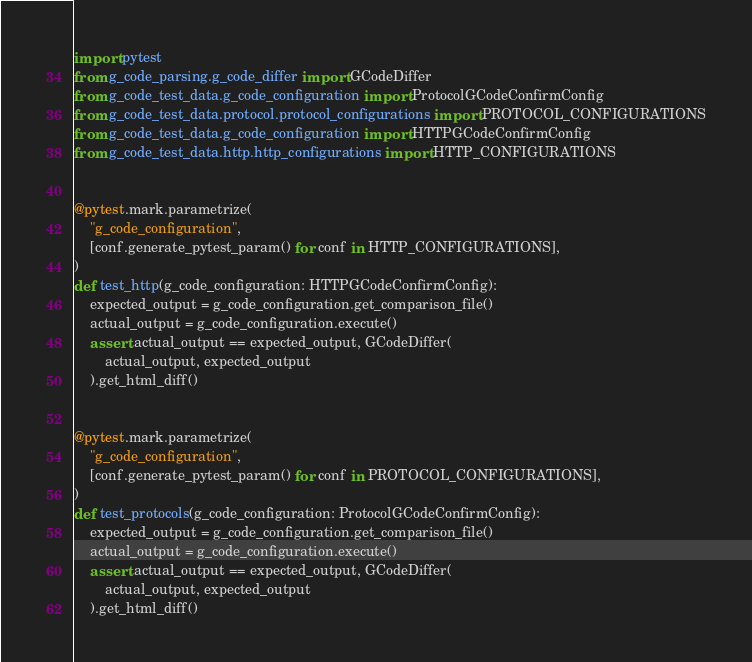Convert code to text. <code><loc_0><loc_0><loc_500><loc_500><_Python_>import pytest
from g_code_parsing.g_code_differ import GCodeDiffer
from g_code_test_data.g_code_configuration import ProtocolGCodeConfirmConfig
from g_code_test_data.protocol.protocol_configurations import PROTOCOL_CONFIGURATIONS
from g_code_test_data.g_code_configuration import HTTPGCodeConfirmConfig
from g_code_test_data.http.http_configurations import HTTP_CONFIGURATIONS


@pytest.mark.parametrize(
    "g_code_configuration",
    [conf.generate_pytest_param() for conf in HTTP_CONFIGURATIONS],
)
def test_http(g_code_configuration: HTTPGCodeConfirmConfig):
    expected_output = g_code_configuration.get_comparison_file()
    actual_output = g_code_configuration.execute()
    assert actual_output == expected_output, GCodeDiffer(
        actual_output, expected_output
    ).get_html_diff()


@pytest.mark.parametrize(
    "g_code_configuration",
    [conf.generate_pytest_param() for conf in PROTOCOL_CONFIGURATIONS],
)
def test_protocols(g_code_configuration: ProtocolGCodeConfirmConfig):
    expected_output = g_code_configuration.get_comparison_file()
    actual_output = g_code_configuration.execute()
    assert actual_output == expected_output, GCodeDiffer(
        actual_output, expected_output
    ).get_html_diff()
</code> 